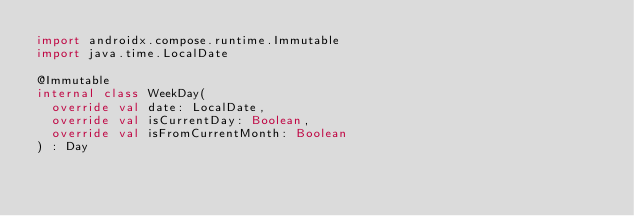<code> <loc_0><loc_0><loc_500><loc_500><_Kotlin_>import androidx.compose.runtime.Immutable
import java.time.LocalDate

@Immutable
internal class WeekDay(
  override val date: LocalDate,
  override val isCurrentDay: Boolean,
  override val isFromCurrentMonth: Boolean
) : Day
</code> 